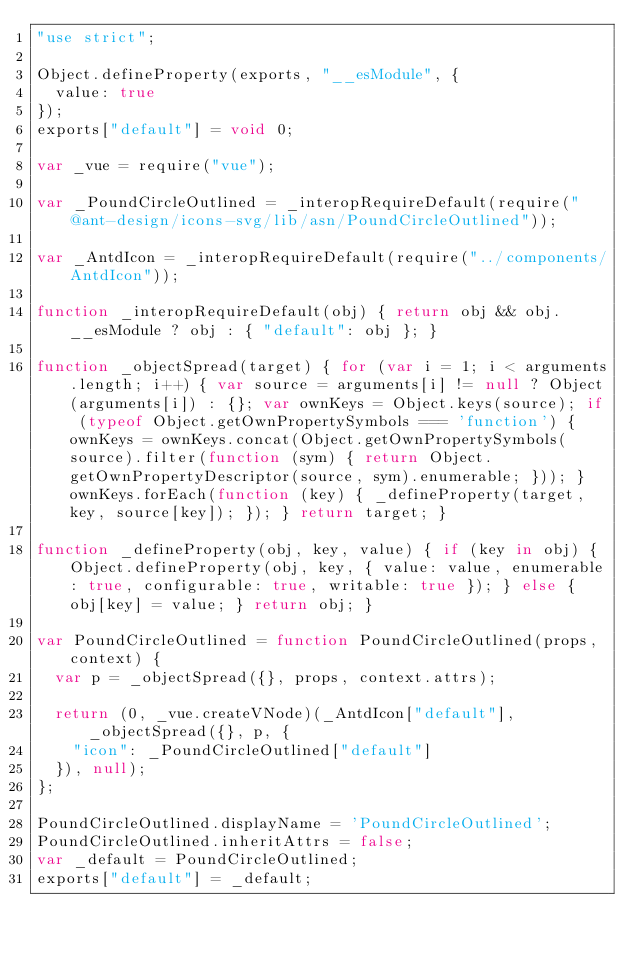<code> <loc_0><loc_0><loc_500><loc_500><_JavaScript_>"use strict";

Object.defineProperty(exports, "__esModule", {
  value: true
});
exports["default"] = void 0;

var _vue = require("vue");

var _PoundCircleOutlined = _interopRequireDefault(require("@ant-design/icons-svg/lib/asn/PoundCircleOutlined"));

var _AntdIcon = _interopRequireDefault(require("../components/AntdIcon"));

function _interopRequireDefault(obj) { return obj && obj.__esModule ? obj : { "default": obj }; }

function _objectSpread(target) { for (var i = 1; i < arguments.length; i++) { var source = arguments[i] != null ? Object(arguments[i]) : {}; var ownKeys = Object.keys(source); if (typeof Object.getOwnPropertySymbols === 'function') { ownKeys = ownKeys.concat(Object.getOwnPropertySymbols(source).filter(function (sym) { return Object.getOwnPropertyDescriptor(source, sym).enumerable; })); } ownKeys.forEach(function (key) { _defineProperty(target, key, source[key]); }); } return target; }

function _defineProperty(obj, key, value) { if (key in obj) { Object.defineProperty(obj, key, { value: value, enumerable: true, configurable: true, writable: true }); } else { obj[key] = value; } return obj; }

var PoundCircleOutlined = function PoundCircleOutlined(props, context) {
  var p = _objectSpread({}, props, context.attrs);

  return (0, _vue.createVNode)(_AntdIcon["default"], _objectSpread({}, p, {
    "icon": _PoundCircleOutlined["default"]
  }), null);
};

PoundCircleOutlined.displayName = 'PoundCircleOutlined';
PoundCircleOutlined.inheritAttrs = false;
var _default = PoundCircleOutlined;
exports["default"] = _default;</code> 